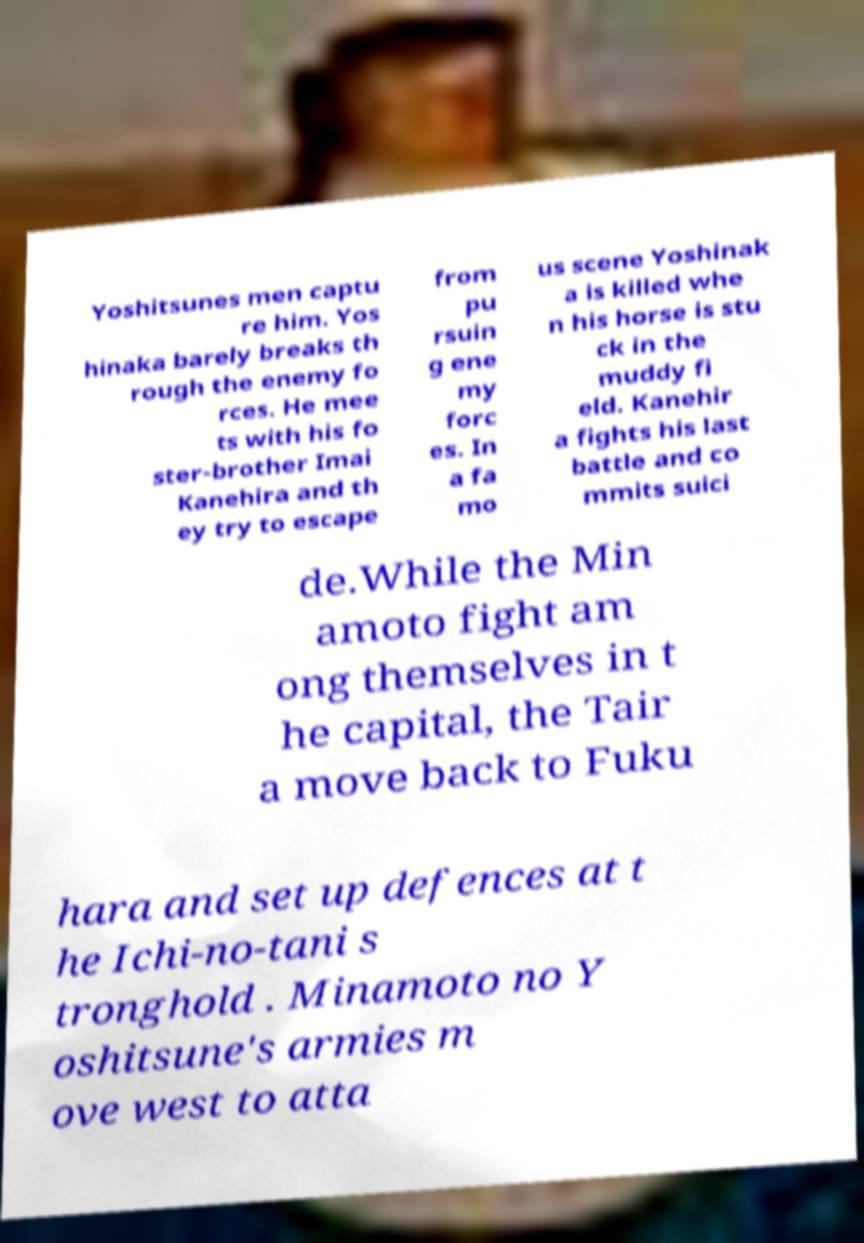For documentation purposes, I need the text within this image transcribed. Could you provide that? Yoshitsunes men captu re him. Yos hinaka barely breaks th rough the enemy fo rces. He mee ts with his fo ster-brother Imai Kanehira and th ey try to escape from pu rsuin g ene my forc es. In a fa mo us scene Yoshinak a is killed whe n his horse is stu ck in the muddy fi eld. Kanehir a fights his last battle and co mmits suici de.While the Min amoto fight am ong themselves in t he capital, the Tair a move back to Fuku hara and set up defences at t he Ichi-no-tani s tronghold . Minamoto no Y oshitsune's armies m ove west to atta 